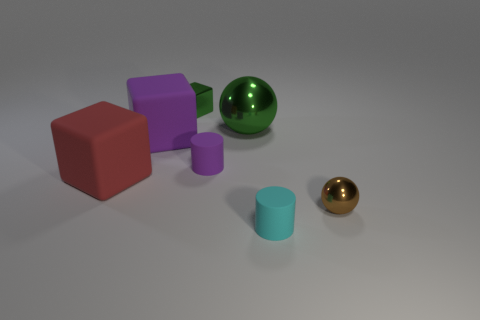Add 1 small metal spheres. How many objects exist? 8 Subtract all balls. How many objects are left? 5 Add 3 big red cubes. How many big red cubes are left? 4 Add 1 purple blocks. How many purple blocks exist? 2 Subtract 1 green balls. How many objects are left? 6 Subtract all cyan matte things. Subtract all big green shiny objects. How many objects are left? 5 